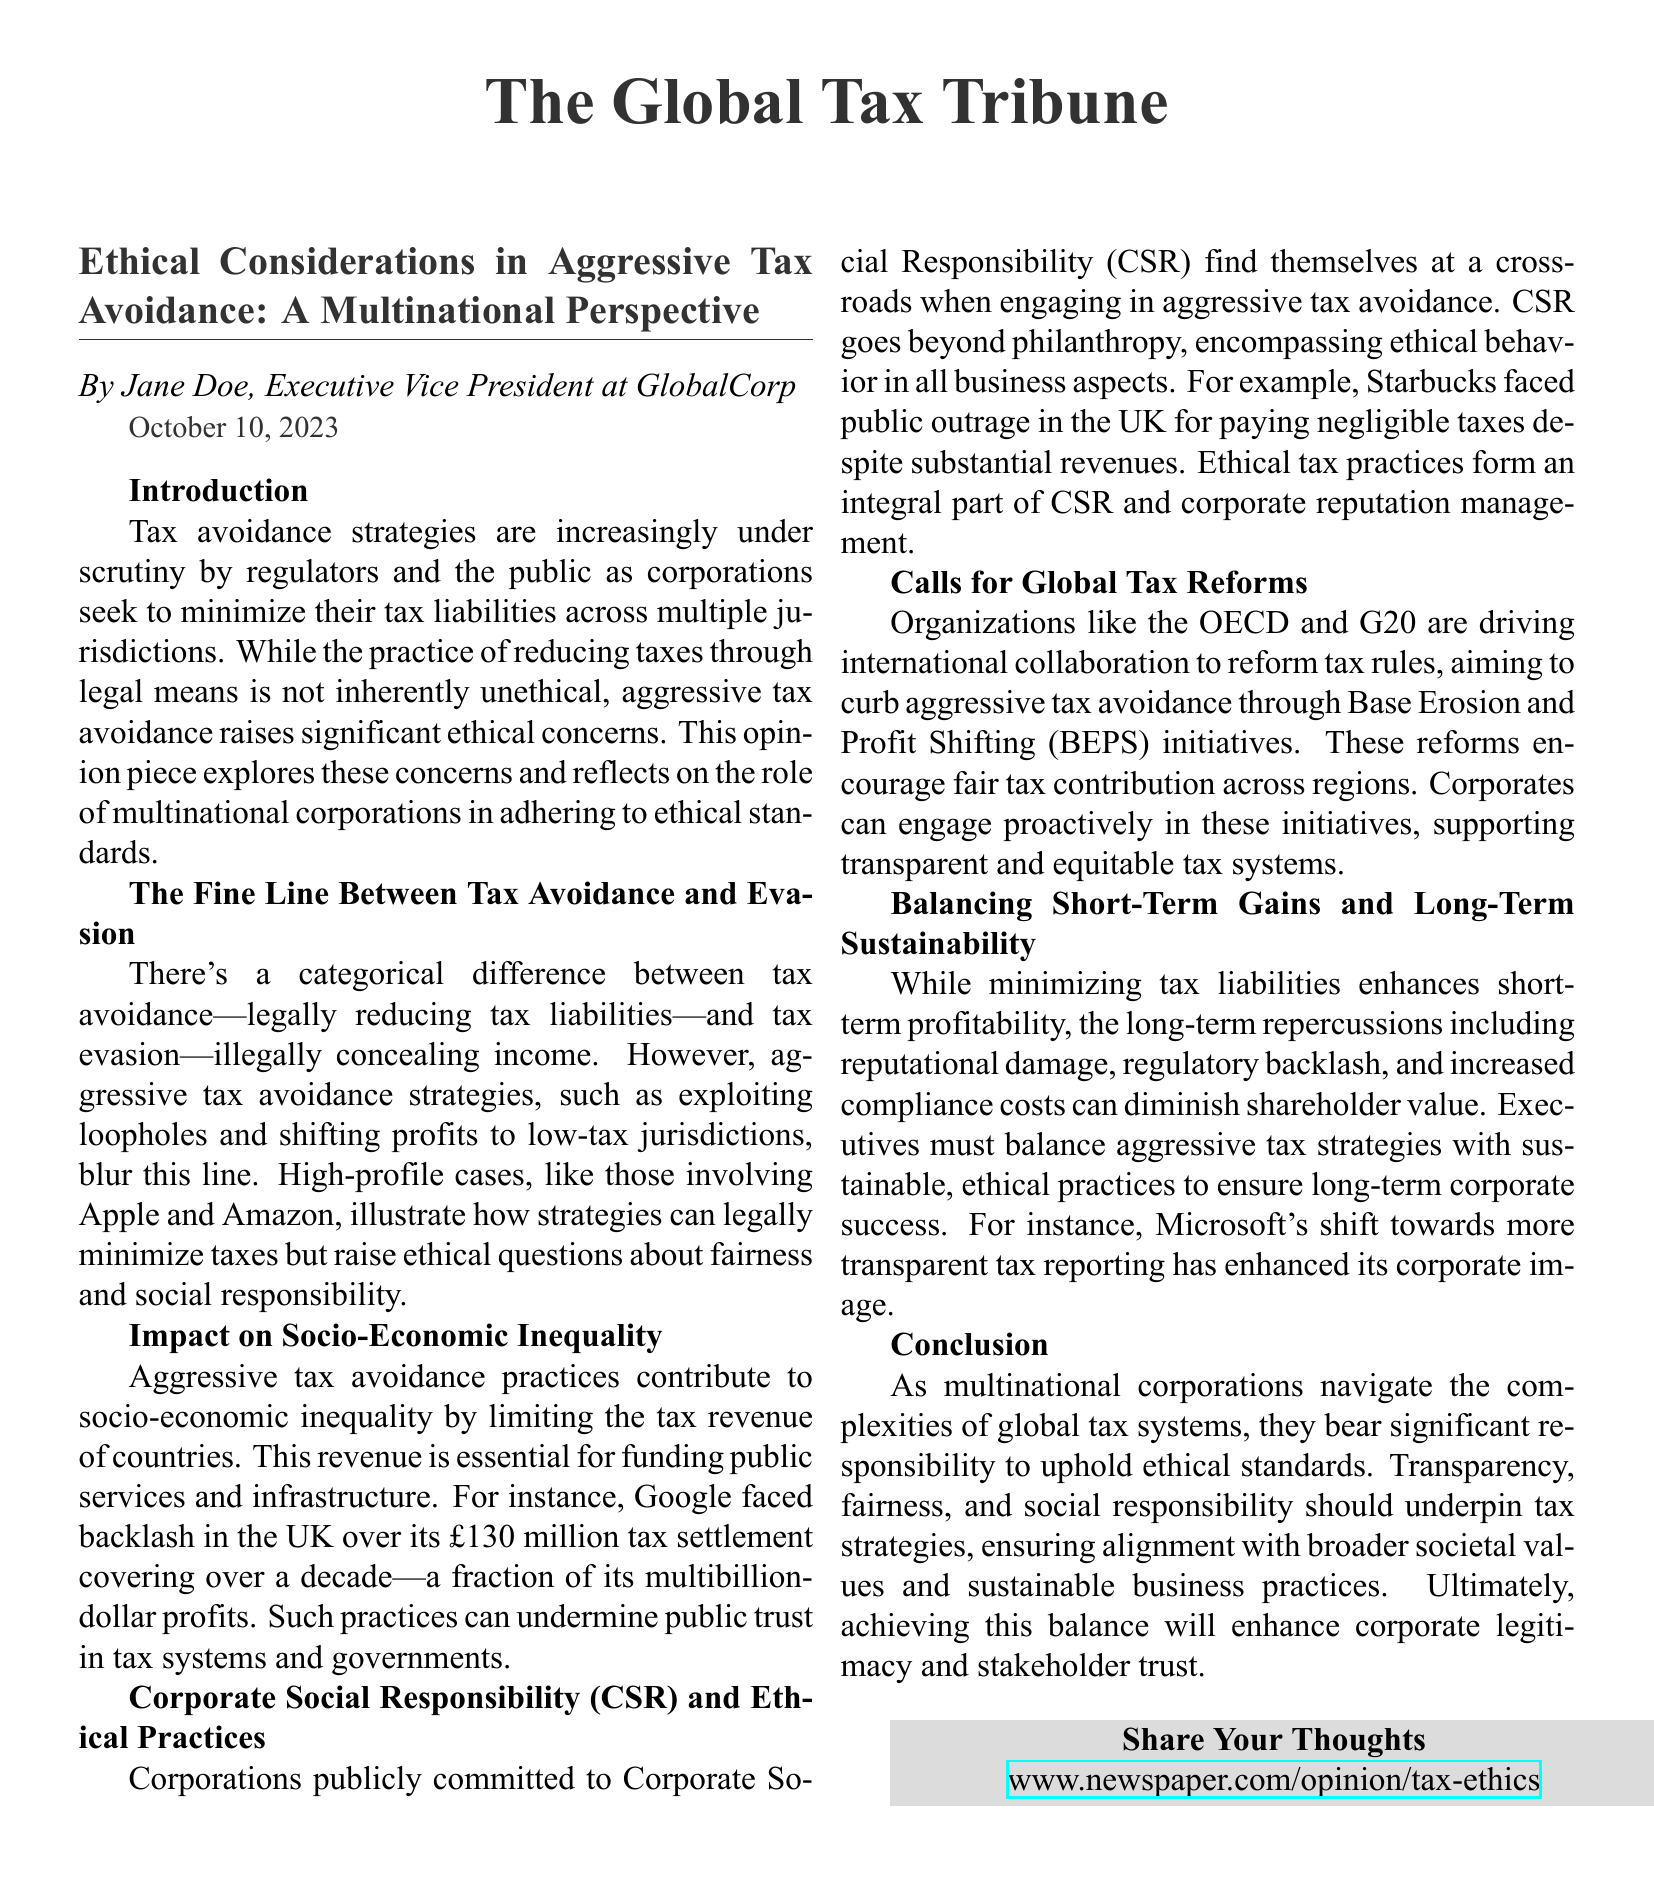what is the publication date? The publication date is explicitly mentioned in the document.
Answer: October 10, 2023 who is the author of the opinion piece? The author is listed at the beginning of the opinion piece.
Answer: Jane Doe what is the main difference between tax avoidance and tax evasion? The document explains this difference in a specific section.
Answer: Legally reducing tax liabilities which company faced backlash in the UK over its tax settlement? The document provides a specific example of this company.
Answer: Google what is the initiative aimed at curbing aggressive tax avoidance? The document mentions an initiative related to tax reforms.
Answer: Base Erosion and Profit Shifting (BEPS) how does aggressive tax avoidance affect public trust? This relationship is discussed in the context of socio-economic implications.
Answer: Undermines public trust what does CSR stand for? The document uses this acronym in connection with corporate practices.
Answer: Corporate Social Responsibility which corporation is cited as an example of ethical tax reporting enhancing corporate image? The document provides a specific example relevant to the topic.
Answer: Microsoft 